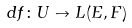Convert formula to latex. <formula><loc_0><loc_0><loc_500><loc_500>d f \colon U \to L ( E , F )</formula> 